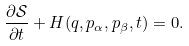Convert formula to latex. <formula><loc_0><loc_0><loc_500><loc_500>\frac { \partial \mathcal { S } } { \partial t } + H ( q , p _ { \alpha } , p _ { \beta } , t ) = 0 .</formula> 